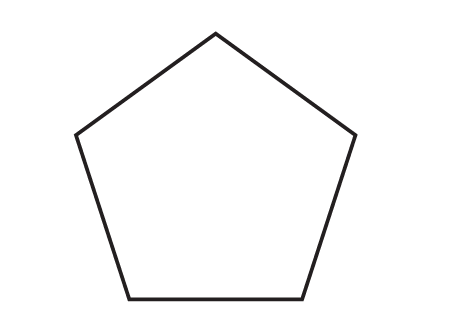Question: What is the measure of an interior angle of a regular pentagon?
Choices:
A. 96
B. 108
C. 120
D. 135
Answer with the letter. Answer: B 